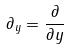<formula> <loc_0><loc_0><loc_500><loc_500>\partial _ { y } = \frac { \partial } { \partial y }</formula> 